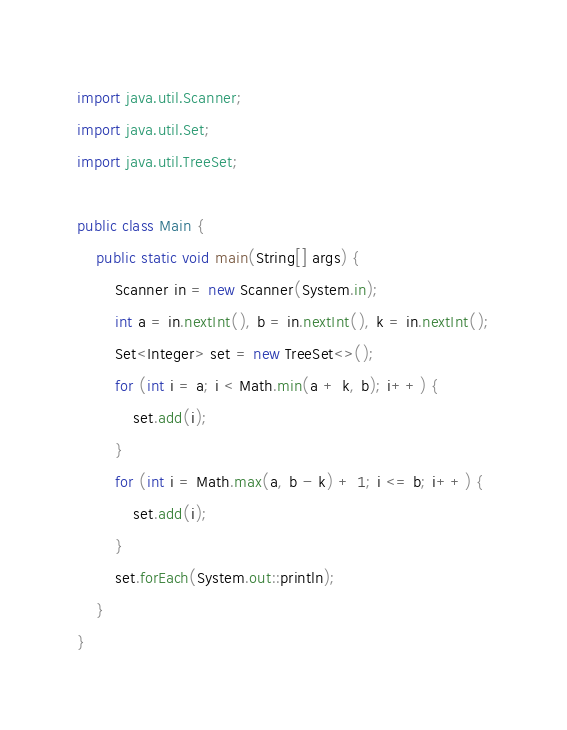Convert code to text. <code><loc_0><loc_0><loc_500><loc_500><_Java_>import java.util.Scanner;
import java.util.Set;
import java.util.TreeSet;

public class Main {
    public static void main(String[] args) {
        Scanner in = new Scanner(System.in);
        int a = in.nextInt(), b = in.nextInt(), k = in.nextInt();
        Set<Integer> set = new TreeSet<>();
        for (int i = a; i < Math.min(a + k, b); i++) {
            set.add(i);
        }
        for (int i = Math.max(a, b - k) + 1; i <= b; i++) {
            set.add(i);
        }
        set.forEach(System.out::println);
    }
}
</code> 